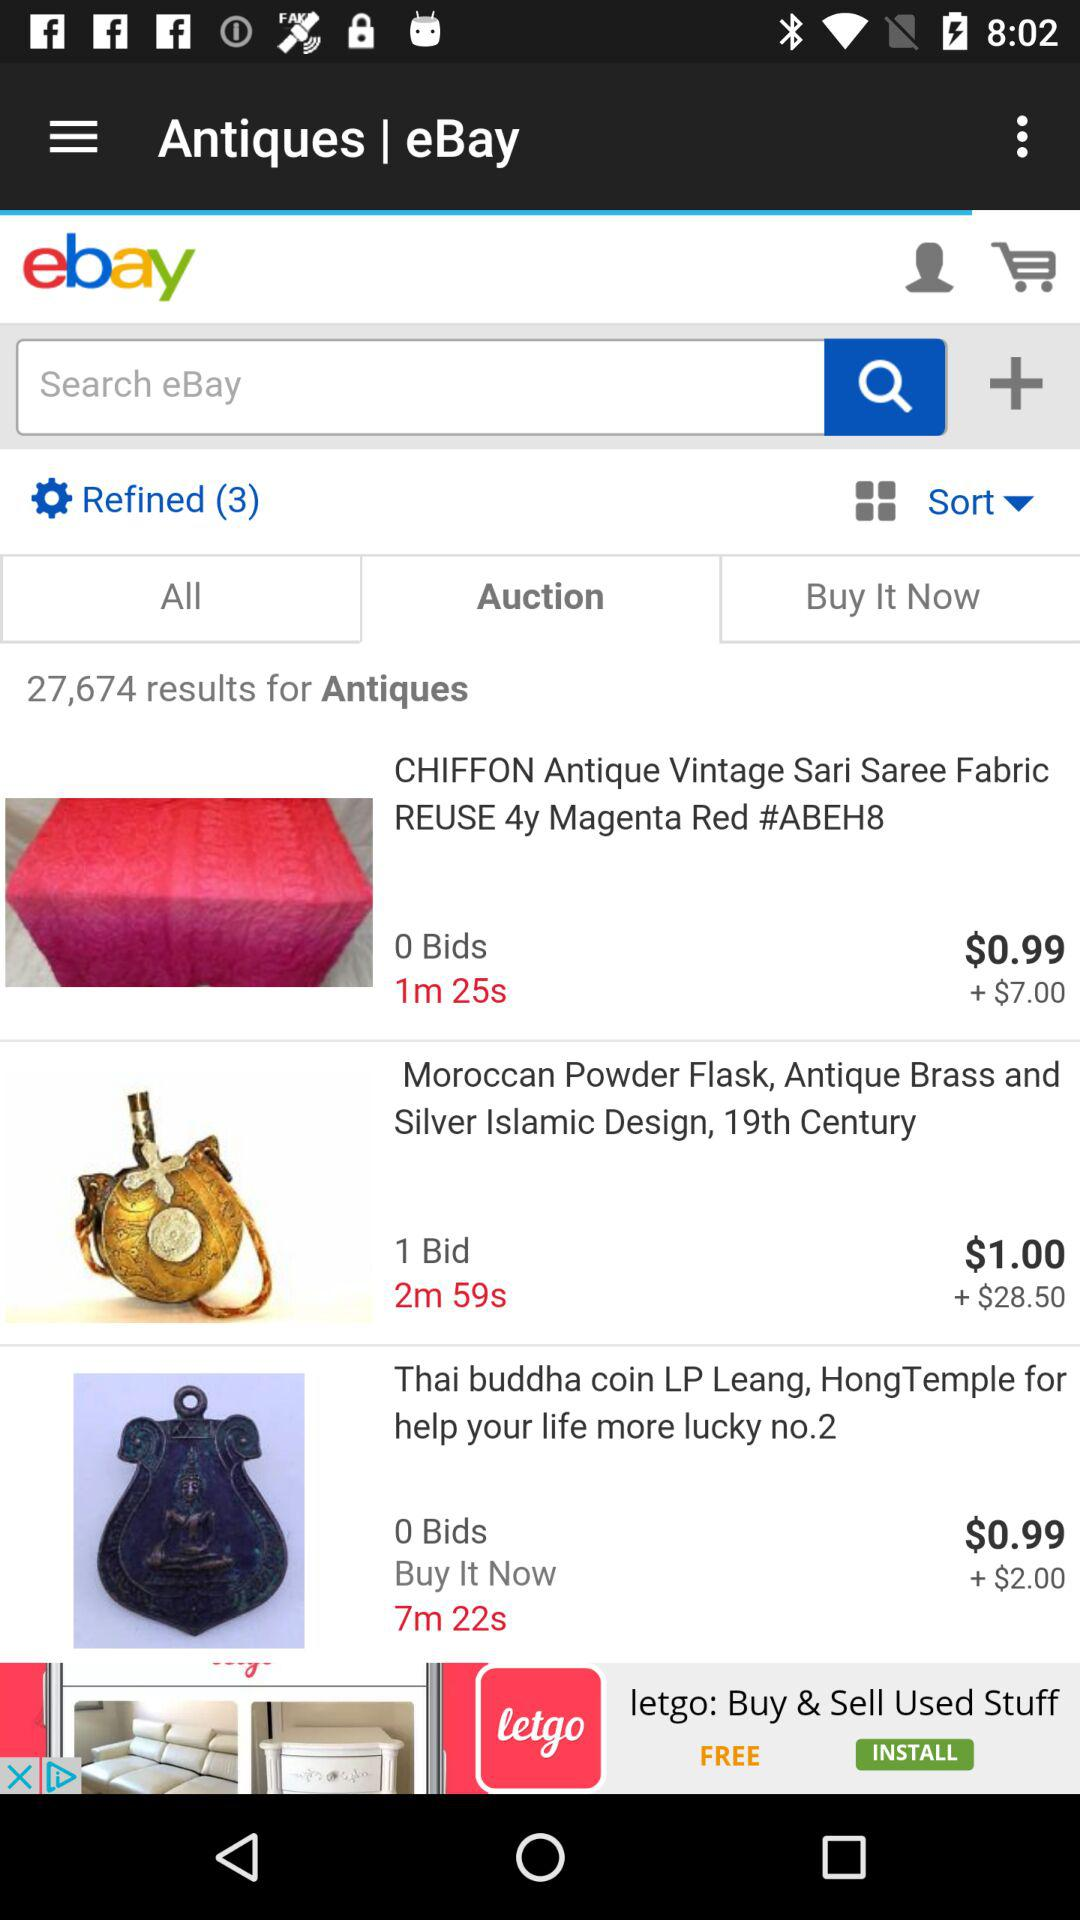How many numbers are there in "Refined"? There are 3 numbers in "Refined". 